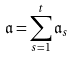Convert formula to latex. <formula><loc_0><loc_0><loc_500><loc_500>\mathfrak { a } = \sum _ { s = 1 } ^ { t } \mathfrak { a } _ { s }</formula> 